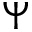<formula> <loc_0><loc_0><loc_500><loc_500>\Psi</formula> 